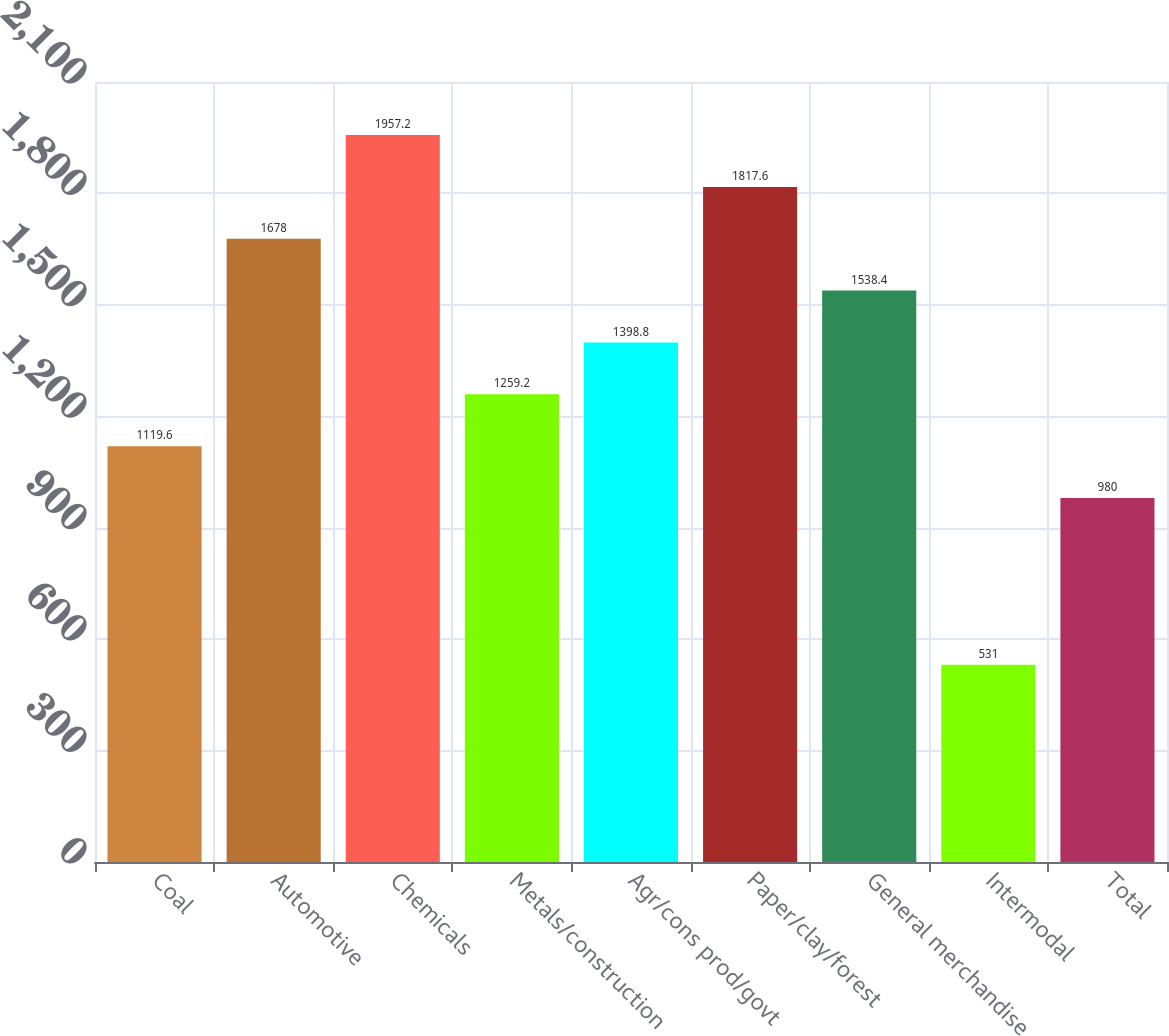Convert chart. <chart><loc_0><loc_0><loc_500><loc_500><bar_chart><fcel>Coal<fcel>Automotive<fcel>Chemicals<fcel>Metals/construction<fcel>Agr/cons prod/govt<fcel>Paper/clay/forest<fcel>General merchandise<fcel>Intermodal<fcel>Total<nl><fcel>1119.6<fcel>1678<fcel>1957.2<fcel>1259.2<fcel>1398.8<fcel>1817.6<fcel>1538.4<fcel>531<fcel>980<nl></chart> 